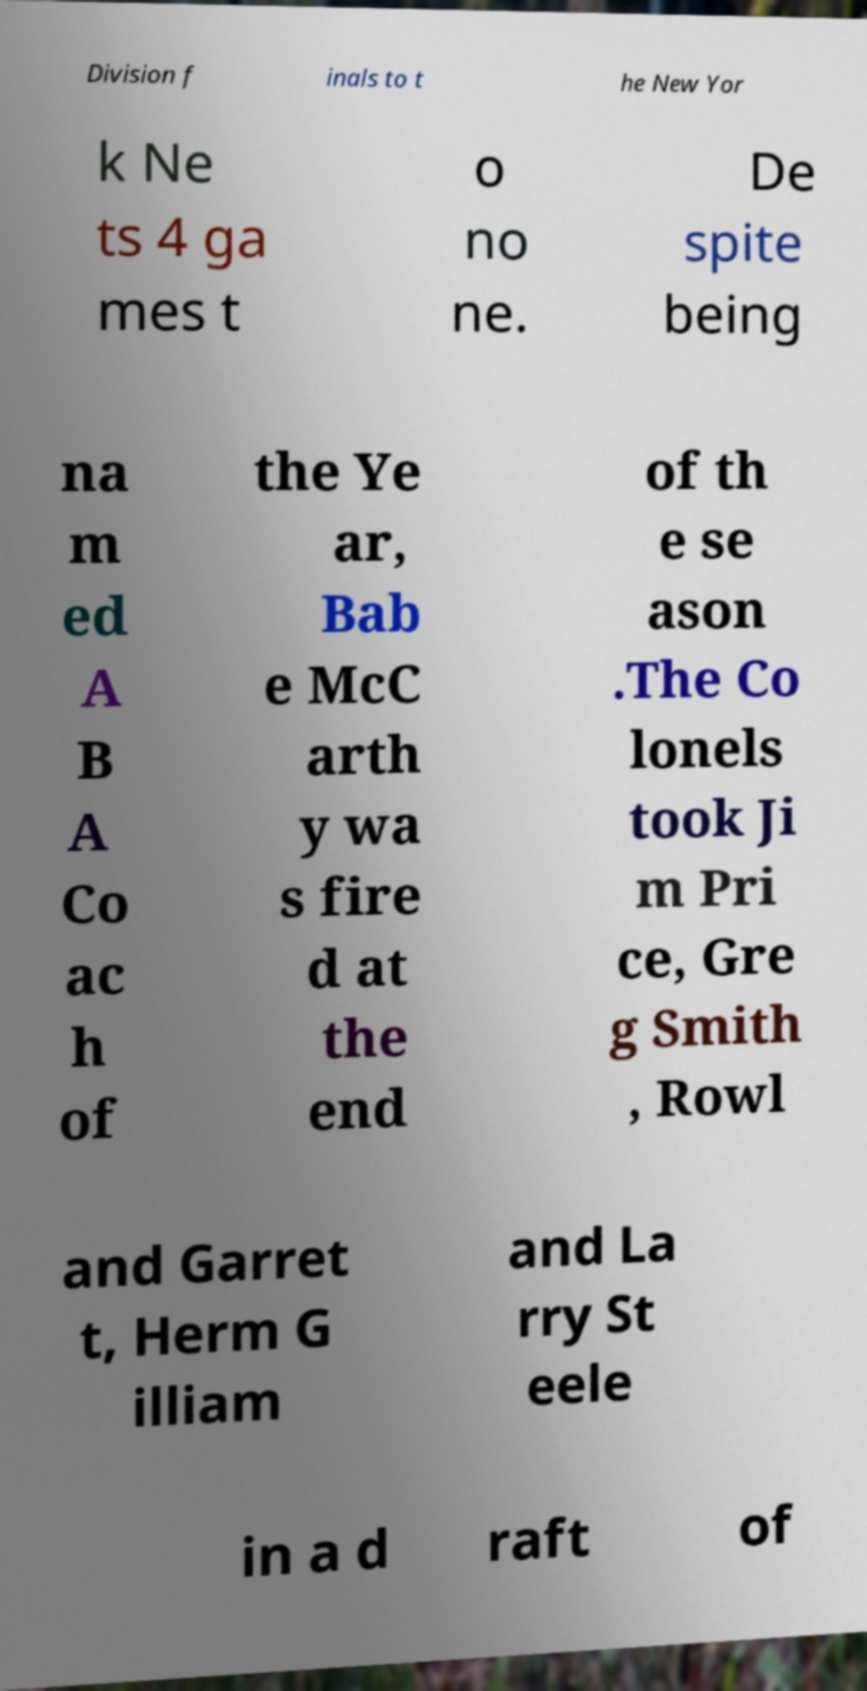Can you read and provide the text displayed in the image?This photo seems to have some interesting text. Can you extract and type it out for me? Division f inals to t he New Yor k Ne ts 4 ga mes t o no ne. De spite being na m ed A B A Co ac h of the Ye ar, Bab e McC arth y wa s fire d at the end of th e se ason .The Co lonels took Ji m Pri ce, Gre g Smith , Rowl and Garret t, Herm G illiam and La rry St eele in a d raft of 